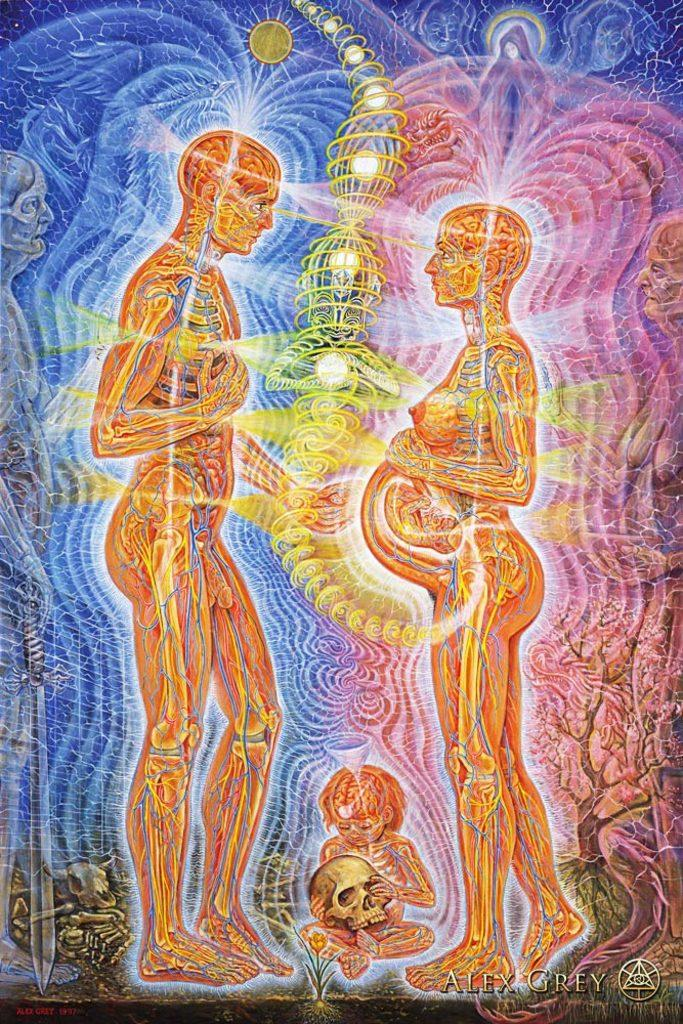How many people are present in the image? There are two people in the image, a man and a woman. What are the genders of the individuals in the image? The man and the woman are the two individuals present in the image. Can you describe the relationship between the man and the woman in the image? The facts provided do not give any information about the relationship between the man and the woman. What type of gun is the man holding in the image? There is no gun present in the image; only a man and a woman are visible. How many chickens are visible in the image? There are no chickens present in the image. 